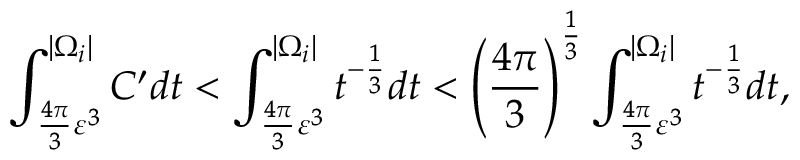Convert formula to latex. <formula><loc_0><loc_0><loc_500><loc_500>\int _ { \frac { 4 \pi } { 3 } \varepsilon ^ { 3 } } ^ { | \Omega _ { i } | } C ^ { \prime } d t < \int _ { \frac { 4 \pi } { 3 } \varepsilon ^ { 3 } } ^ { | \Omega _ { i } | } t ^ { - \frac { 1 } { 3 } } d t < \left ( \frac { 4 \pi } { 3 } \right ) ^ { \frac { 1 } { 3 } } \int _ { \frac { 4 \pi } { 3 } \varepsilon ^ { 3 } } ^ { | \Omega _ { i } | } t ^ { - \frac { 1 } { 3 } } d t ,</formula> 